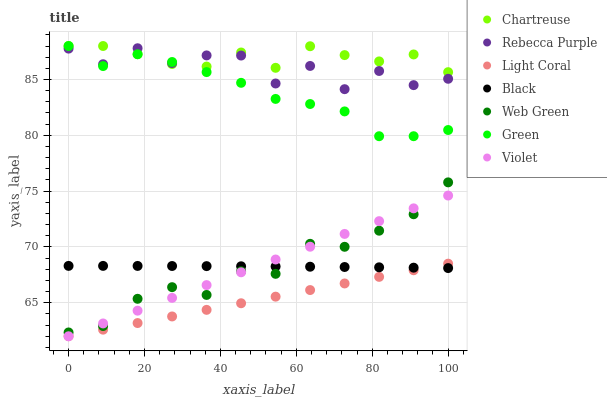Does Light Coral have the minimum area under the curve?
Answer yes or no. Yes. Does Chartreuse have the maximum area under the curve?
Answer yes or no. Yes. Does Chartreuse have the minimum area under the curve?
Answer yes or no. No. Does Light Coral have the maximum area under the curve?
Answer yes or no. No. Is Light Coral the smoothest?
Answer yes or no. Yes. Is Rebecca Purple the roughest?
Answer yes or no. Yes. Is Chartreuse the smoothest?
Answer yes or no. No. Is Chartreuse the roughest?
Answer yes or no. No. Does Light Coral have the lowest value?
Answer yes or no. Yes. Does Chartreuse have the lowest value?
Answer yes or no. No. Does Green have the highest value?
Answer yes or no. Yes. Does Light Coral have the highest value?
Answer yes or no. No. Is Violet less than Green?
Answer yes or no. Yes. Is Chartreuse greater than Black?
Answer yes or no. Yes. Does Black intersect Violet?
Answer yes or no. Yes. Is Black less than Violet?
Answer yes or no. No. Is Black greater than Violet?
Answer yes or no. No. Does Violet intersect Green?
Answer yes or no. No. 